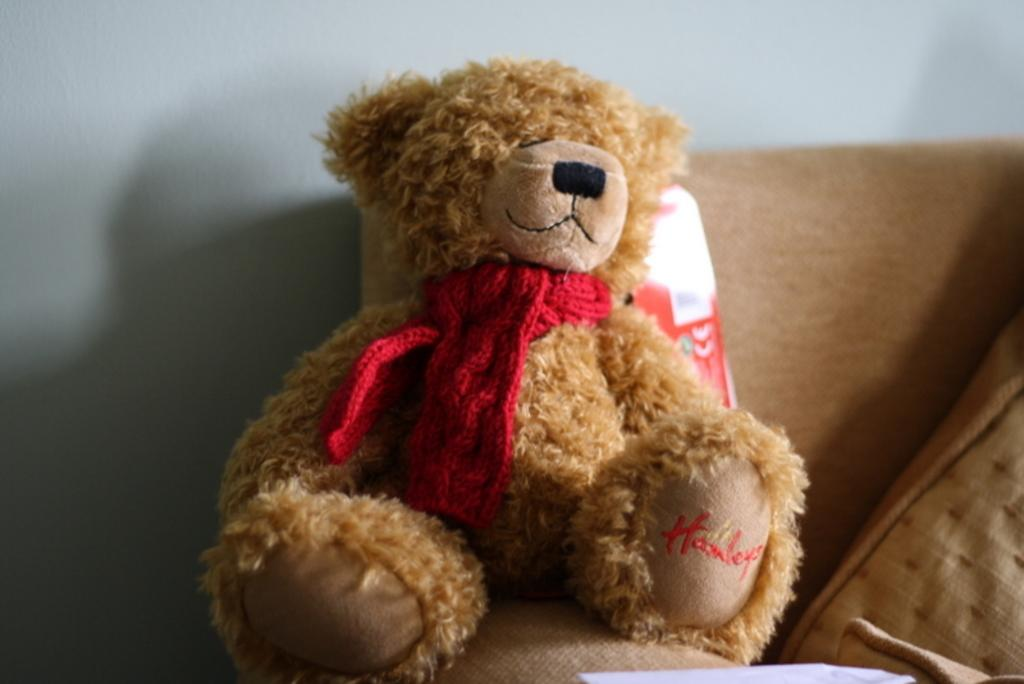What type of toy is in the image? There is a teddy bear in the image. What color is the teddy bear? The teddy bear is brown in color. What type of furniture is in the image? There is a sofa in the image. What type of flame can be seen on the teddy bear in the image? There is no flame present on the teddy bear in the image. 